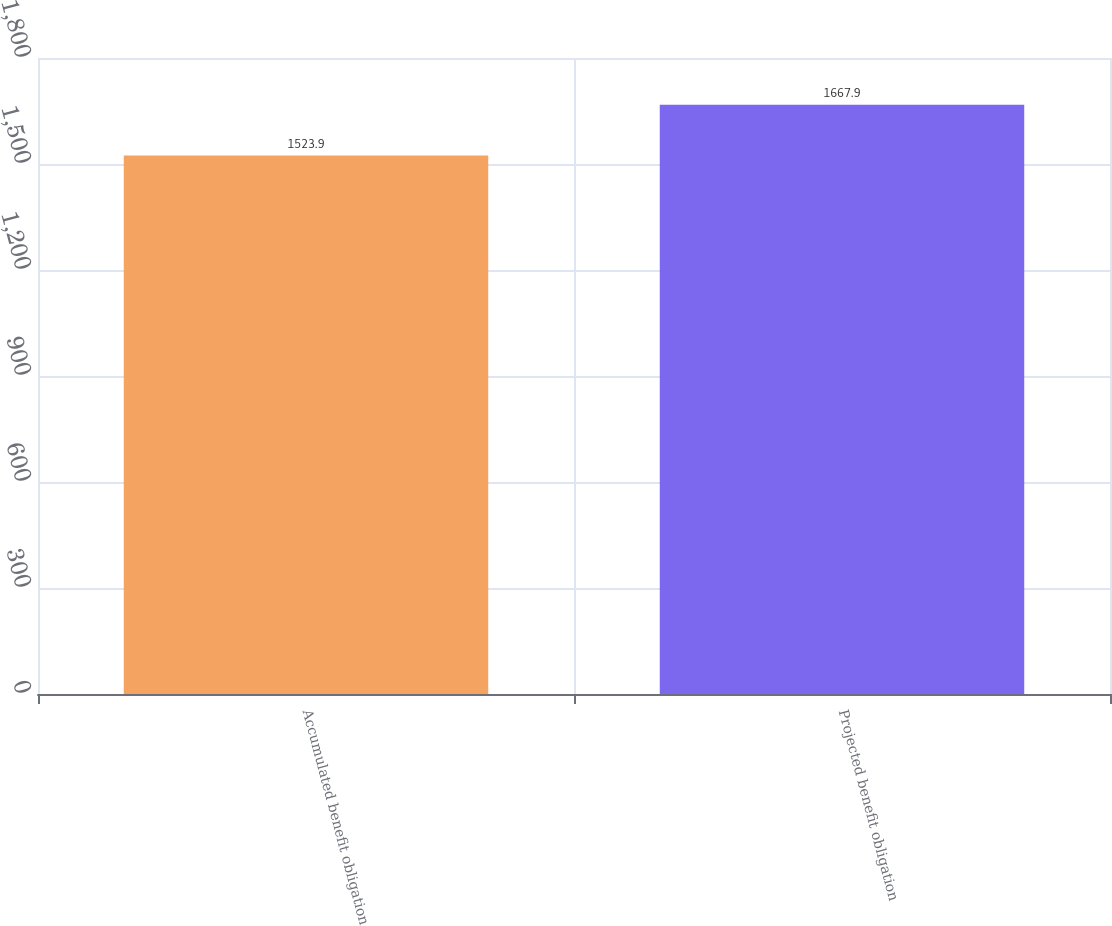<chart> <loc_0><loc_0><loc_500><loc_500><bar_chart><fcel>Accumulated benefit obligation<fcel>Projected benefit obligation<nl><fcel>1523.9<fcel>1667.9<nl></chart> 